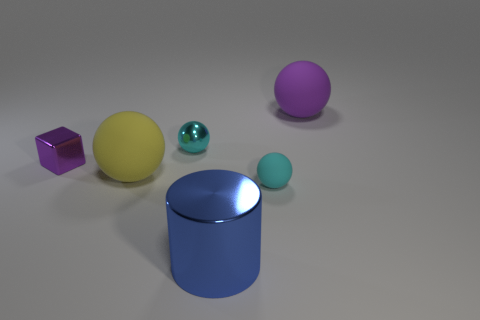There is a purple object that is on the left side of the blue thing; is it the same shape as the big yellow rubber object right of the purple block?
Keep it short and to the point. No. Is there a blue metallic object of the same size as the yellow thing?
Keep it short and to the point. Yes. There is a small cyan ball behind the small rubber ball; what is its material?
Make the answer very short. Metal. Is the tiny sphere in front of the cyan metal object made of the same material as the blue thing?
Your response must be concise. No. Is there a tiny ball?
Provide a succinct answer. Yes. The large cylinder that is the same material as the tiny purple object is what color?
Make the answer very short. Blue. What is the color of the matte thing that is on the right side of the cyan ball that is in front of the rubber sphere that is to the left of the large blue object?
Give a very brief answer. Purple. Does the shiny ball have the same size as the purple thing that is on the right side of the big blue metal thing?
Your answer should be compact. No. How many objects are either tiny objects behind the small matte ball or small things that are on the left side of the tiny cyan matte ball?
Ensure brevity in your answer.  2. What shape is the purple thing that is the same size as the cyan matte thing?
Offer a terse response. Cube. 